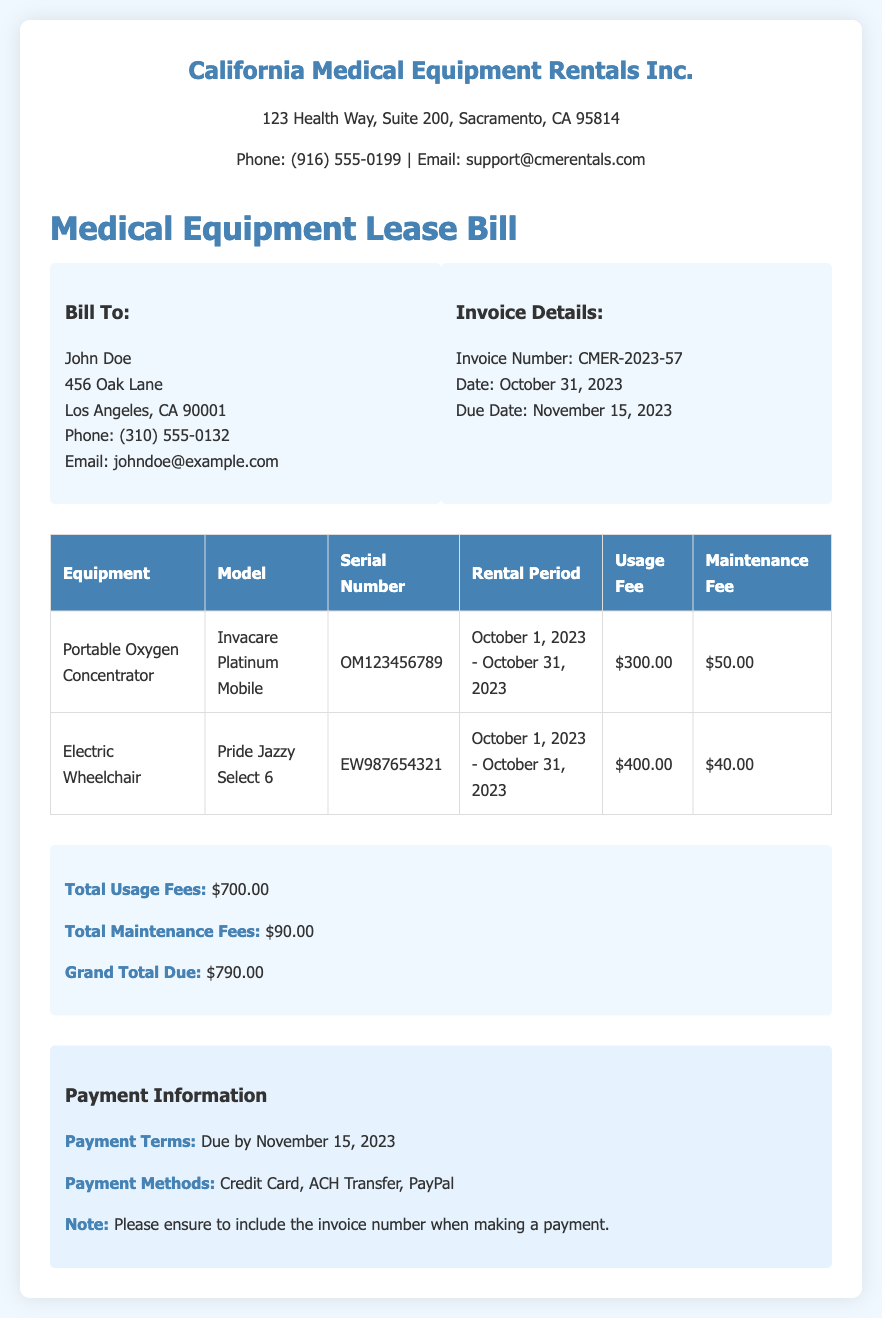What is the invoice number? The invoice number is stated under the Invoice Details section of the document.
Answer: CMER-2023-57 What is the total grand amount due? The grand total due is highlighted in the total section of the document.
Answer: $790.00 What equipment is listed with the serial number OM123456789? The equipment corresponding to the serial number can be found in the table section of the document.
Answer: Portable Oxygen Concentrator What is the maintenance fee for the Electric Wheelchair? The maintenance fee can be found in the table next to the Electric Wheelchair entry.
Answer: $40.00 When is the payment due? The due date is mentioned in the Invoice Details section of the document.
Answer: November 15, 2023 What is the total usage fee? The total usage fees are summarized in the total section of the document.
Answer: $700.00 Which model of the portable oxygen concentrator is leased? The model is specified in the equipment table in the document.
Answer: Invacare Platinum Mobile What payment methods are available? The payment methods are listed in the payment information section of the document.
Answer: Credit Card, ACH Transfer, PayPal What is the rental period for the equipment? The rental period was defined in the table next to each piece of equipment in the document.
Answer: October 1, 2023 - October 31, 2023 